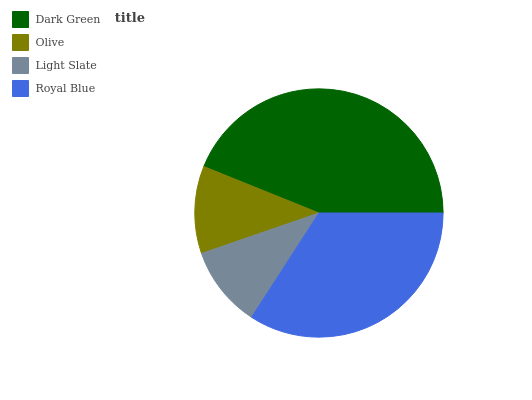Is Light Slate the minimum?
Answer yes or no. Yes. Is Dark Green the maximum?
Answer yes or no. Yes. Is Olive the minimum?
Answer yes or no. No. Is Olive the maximum?
Answer yes or no. No. Is Dark Green greater than Olive?
Answer yes or no. Yes. Is Olive less than Dark Green?
Answer yes or no. Yes. Is Olive greater than Dark Green?
Answer yes or no. No. Is Dark Green less than Olive?
Answer yes or no. No. Is Royal Blue the high median?
Answer yes or no. Yes. Is Olive the low median?
Answer yes or no. Yes. Is Olive the high median?
Answer yes or no. No. Is Dark Green the low median?
Answer yes or no. No. 